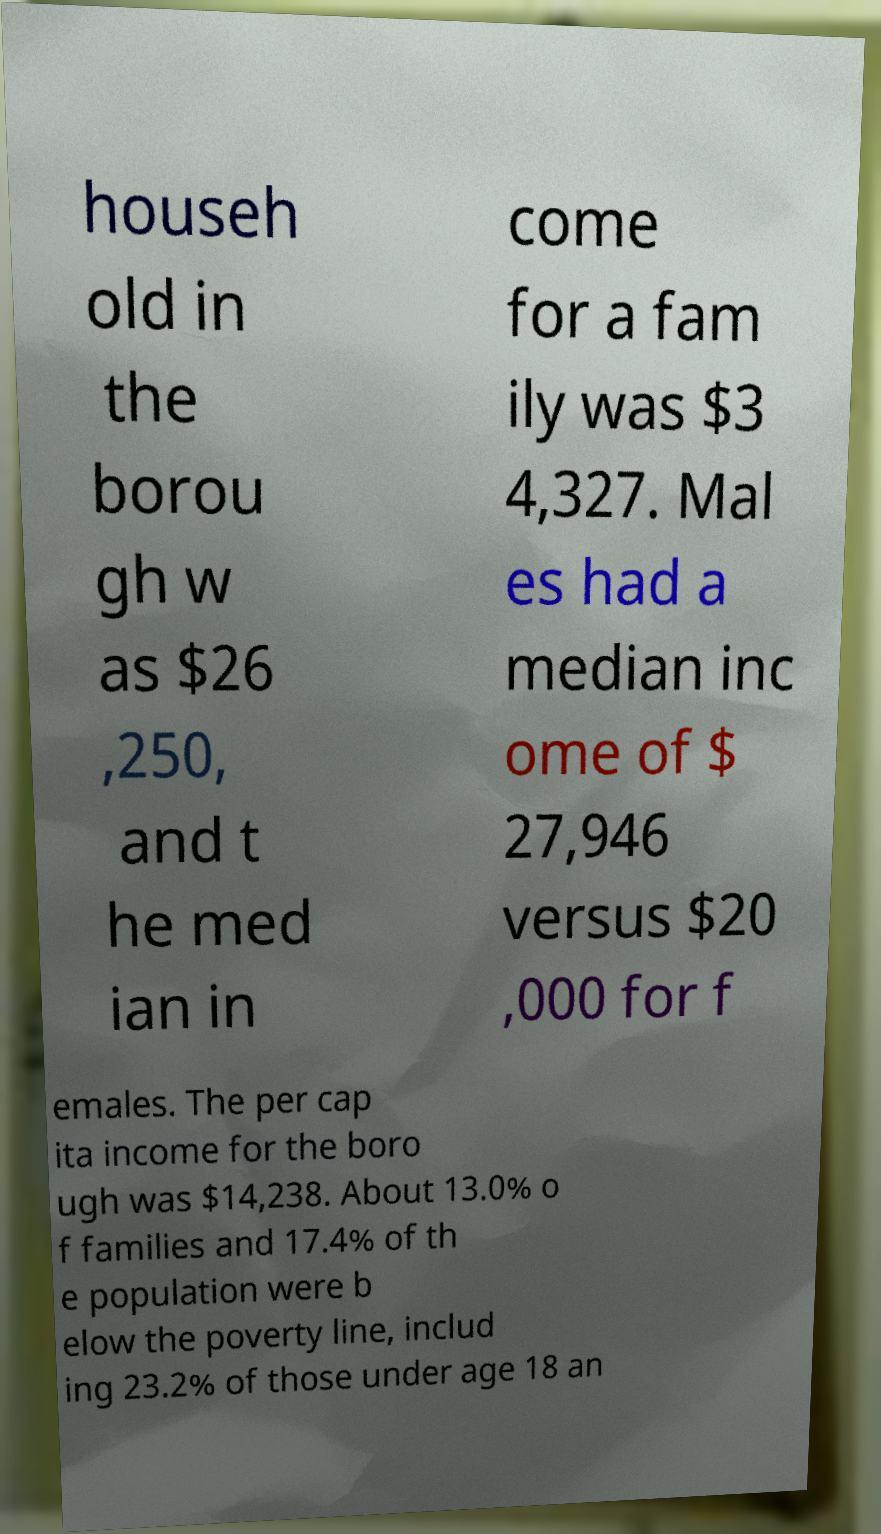I need the written content from this picture converted into text. Can you do that? househ old in the borou gh w as $26 ,250, and t he med ian in come for a fam ily was $3 4,327. Mal es had a median inc ome of $ 27,946 versus $20 ,000 for f emales. The per cap ita income for the boro ugh was $14,238. About 13.0% o f families and 17.4% of th e population were b elow the poverty line, includ ing 23.2% of those under age 18 an 